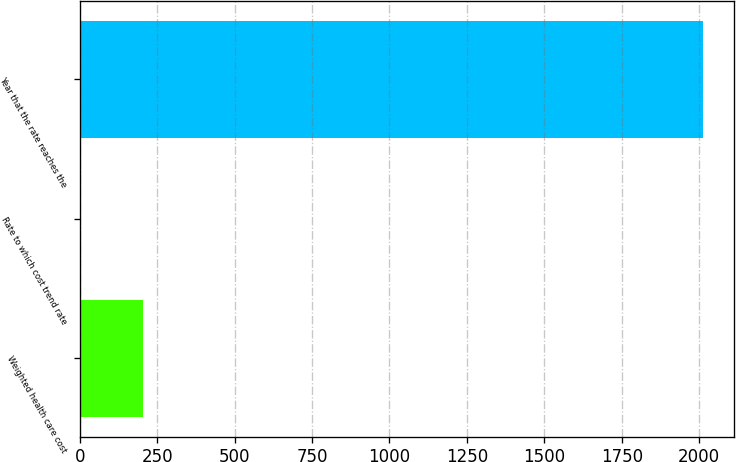Convert chart to OTSL. <chart><loc_0><loc_0><loc_500><loc_500><bar_chart><fcel>Weighted health care cost<fcel>Rate to which cost trend rate<fcel>Year that the rate reaches the<nl><fcel>205.07<fcel>4.3<fcel>2012<nl></chart> 